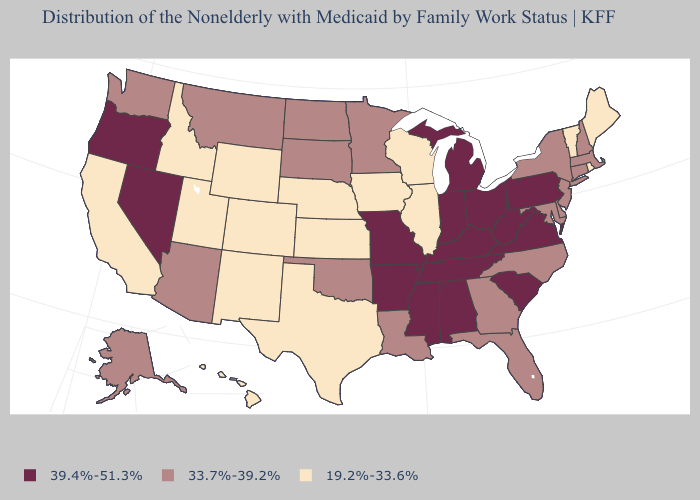Does the first symbol in the legend represent the smallest category?
Write a very short answer. No. Name the states that have a value in the range 39.4%-51.3%?
Keep it brief. Alabama, Arkansas, Indiana, Kentucky, Michigan, Mississippi, Missouri, Nevada, Ohio, Oregon, Pennsylvania, South Carolina, Tennessee, Virginia, West Virginia. Does Nevada have the highest value in the West?
Be succinct. Yes. What is the value of Louisiana?
Give a very brief answer. 33.7%-39.2%. Name the states that have a value in the range 39.4%-51.3%?
Write a very short answer. Alabama, Arkansas, Indiana, Kentucky, Michigan, Mississippi, Missouri, Nevada, Ohio, Oregon, Pennsylvania, South Carolina, Tennessee, Virginia, West Virginia. What is the highest value in the MidWest ?
Write a very short answer. 39.4%-51.3%. Does Florida have the lowest value in the USA?
Short answer required. No. Among the states that border Idaho , which have the highest value?
Give a very brief answer. Nevada, Oregon. What is the value of Alaska?
Be succinct. 33.7%-39.2%. What is the highest value in the Northeast ?
Give a very brief answer. 39.4%-51.3%. What is the lowest value in the Northeast?
Keep it brief. 19.2%-33.6%. Name the states that have a value in the range 33.7%-39.2%?
Give a very brief answer. Alaska, Arizona, Connecticut, Delaware, Florida, Georgia, Louisiana, Maryland, Massachusetts, Minnesota, Montana, New Hampshire, New Jersey, New York, North Carolina, North Dakota, Oklahoma, South Dakota, Washington. Does Hawaii have the lowest value in the West?
Short answer required. Yes. Which states have the highest value in the USA?
Quick response, please. Alabama, Arkansas, Indiana, Kentucky, Michigan, Mississippi, Missouri, Nevada, Ohio, Oregon, Pennsylvania, South Carolina, Tennessee, Virginia, West Virginia. What is the lowest value in the USA?
Answer briefly. 19.2%-33.6%. 